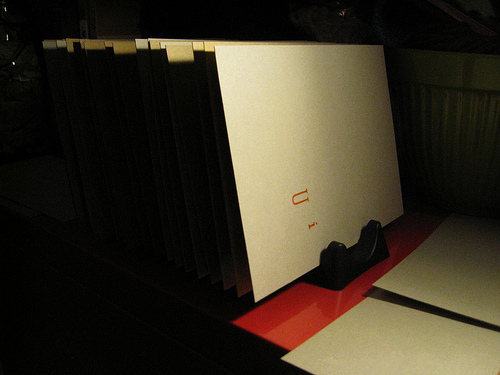<image>
Can you confirm if the holder is on the folder? No. The holder is not positioned on the folder. They may be near each other, but the holder is not supported by or resting on top of the folder. 